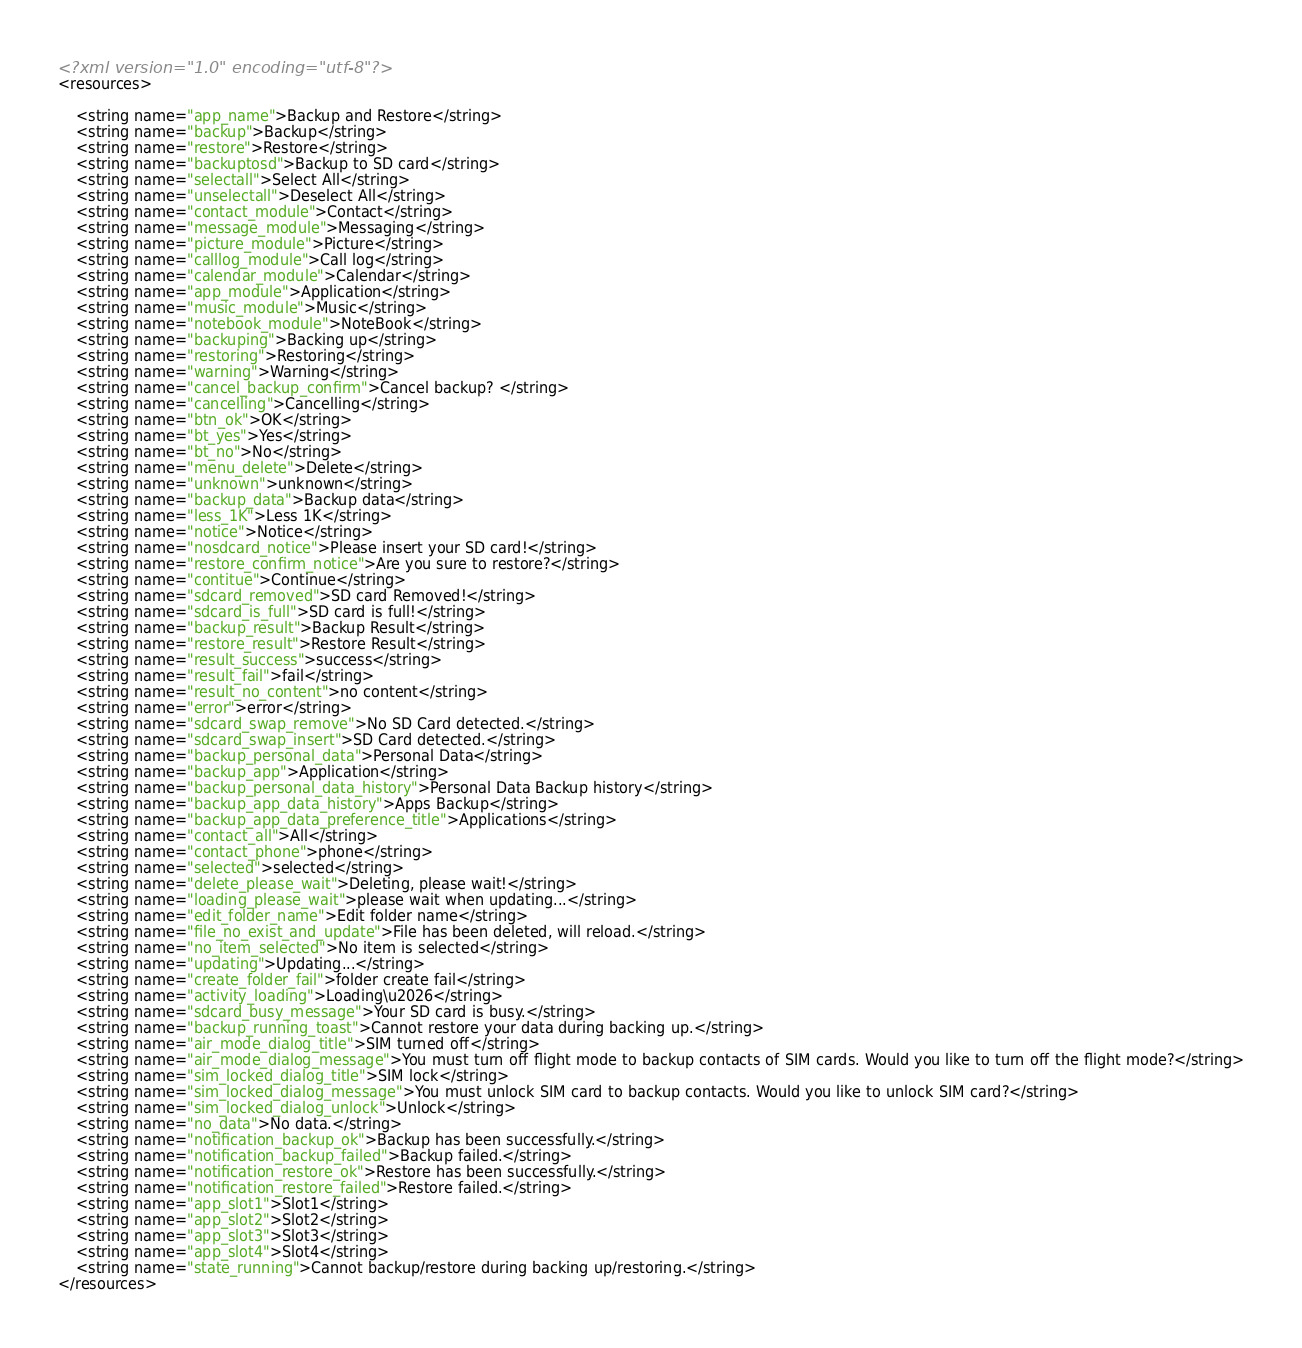Convert code to text. <code><loc_0><loc_0><loc_500><loc_500><_XML_><?xml version="1.0" encoding="utf-8"?>
<resources>

    <string name="app_name">Backup and Restore</string>
    <string name="backup">Backup</string>
    <string name="restore">Restore</string>
    <string name="backuptosd">Backup to SD card</string>
    <string name="selectall">Select All</string>
    <string name="unselectall">Deselect All</string>
    <string name="contact_module">Contact</string>
    <string name="message_module">Messaging</string>
    <string name="picture_module">Picture</string>
    <string name="calllog_module">Call log</string>
    <string name="calendar_module">Calendar</string>
    <string name="app_module">Application</string>
    <string name="music_module">Music</string>
    <string name="notebook_module">NoteBook</string>
    <string name="backuping">Backing up</string>
    <string name="restoring">Restoring</string>
    <string name="warning">Warning</string>
    <string name="cancel_backup_confirm">Cancel backup? </string>
    <string name="cancelling">Cancelling</string>
    <string name="btn_ok">OK</string>
    <string name="bt_yes">Yes</string>
    <string name="bt_no">No</string>
    <string name="menu_delete">Delete</string>
    <string name="unknown">unknown</string>
    <string name="backup_data">Backup data</string>
    <string name="less_1K">Less 1K</string>
    <string name="notice">Notice</string>
    <string name="nosdcard_notice">Please insert your SD card!</string>
    <string name="restore_confirm_notice">Are you sure to restore?</string>
    <string name="contitue">Continue</string>
    <string name="sdcard_removed">SD card Removed!</string>
    <string name="sdcard_is_full">SD card is full!</string>
    <string name="backup_result">Backup Result</string>
    <string name="restore_result">Restore Result</string>
    <string name="result_success">success</string>
    <string name="result_fail">fail</string>
    <string name="result_no_content">no content</string>
    <string name="error">error</string>
    <string name="sdcard_swap_remove">No SD Card detected.</string>
    <string name="sdcard_swap_insert">SD Card detected.</string>
    <string name="backup_personal_data">Personal Data</string>
    <string name="backup_app">Application</string>
    <string name="backup_personal_data_history">Personal Data Backup history</string>
    <string name="backup_app_data_history">Apps Backup</string>
    <string name="backup_app_data_preference_title">Applications</string>
    <string name="contact_all">All</string>
    <string name="contact_phone">phone</string>
    <string name="selected">selected</string>
    <string name="delete_please_wait">Deleting, please wait!</string>
    <string name="loading_please_wait">please wait when updating...</string>
    <string name="edit_folder_name">Edit folder name</string>
    <string name="file_no_exist_and_update">File has been deleted, will reload.</string>
    <string name="no_item_selected">No item is selected</string>
    <string name="updating">Updating...</string>
    <string name="create_folder_fail">folder create fail</string>
    <string name="activity_loading">Loading\u2026</string>
    <string name="sdcard_busy_message">Your SD card is busy.</string>
    <string name="backup_running_toast">Cannot restore your data during backing up.</string>
    <string name="air_mode_dialog_title">SIM turned off</string>
    <string name="air_mode_dialog_message">You must turn off flight mode to backup contacts of SIM cards. Would you like to turn off the flight mode?</string>
    <string name="sim_locked_dialog_title">SIM lock</string>
    <string name="sim_locked_dialog_message">You must unlock SIM card to backup contacts. Would you like to unlock SIM card?</string>
    <string name="sim_locked_dialog_unlock">Unlock</string>
    <string name="no_data">No data.</string>
    <string name="notification_backup_ok">Backup has been successfully.</string>
    <string name="notification_backup_failed">Backup failed.</string>
    <string name="notification_restore_ok">Restore has been successfully.</string>
    <string name="notification_restore_failed">Restore failed.</string>
    <string name="app_slot1">Slot1</string>
    <string name="app_slot2">Slot2</string>
    <string name="app_slot3">Slot3</string>
    <string name="app_slot4">Slot4</string>
    <string name="state_running">Cannot backup/restore during backing up/restoring.</string>
</resources>
</code> 